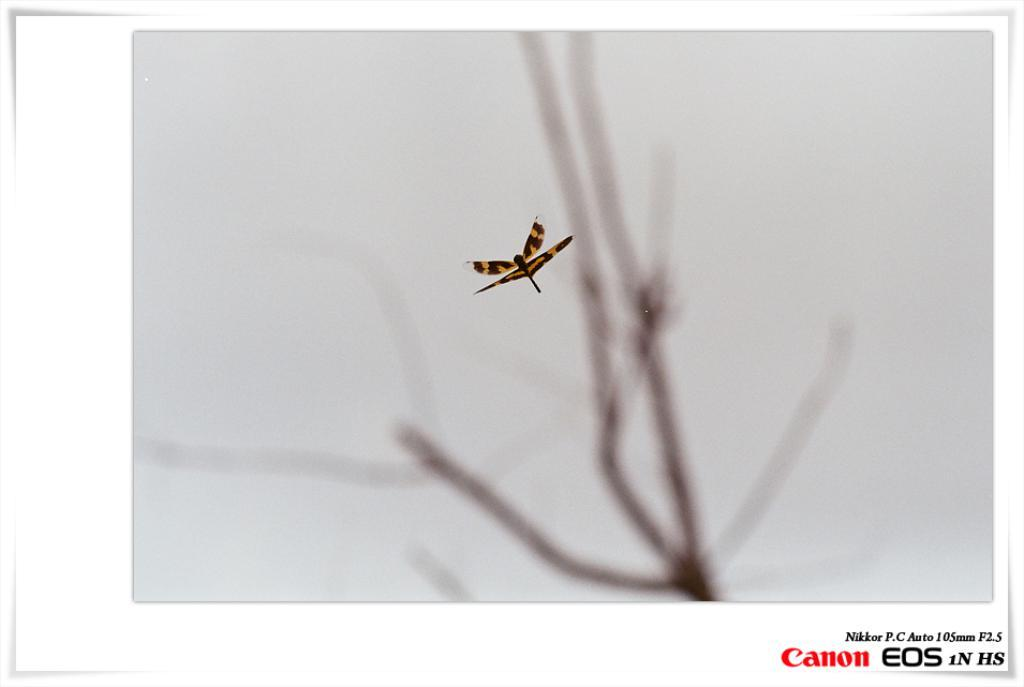What type of creature is present in the image? There is an insect in the image. What colors can be seen on the insect? The insect is black and yellow in color. What type of vegetation is visible in the image? There are branches of a tree in the image. What part of the natural environment is visible in the image? The sky is visible in the image. What type of glass is being traded in the image? There is no reference to glass or trade in the image, so it's not possible to answer that question. 